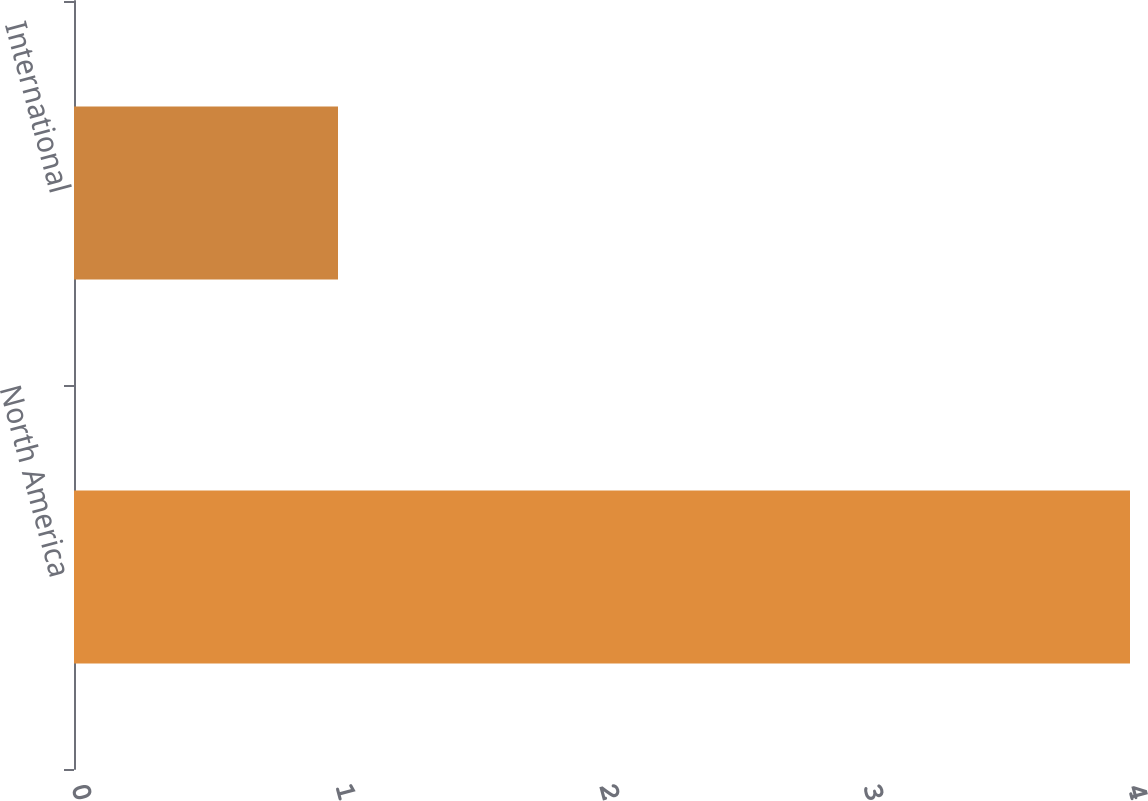Convert chart to OTSL. <chart><loc_0><loc_0><loc_500><loc_500><bar_chart><fcel>North America<fcel>International<nl><fcel>4<fcel>1<nl></chart> 